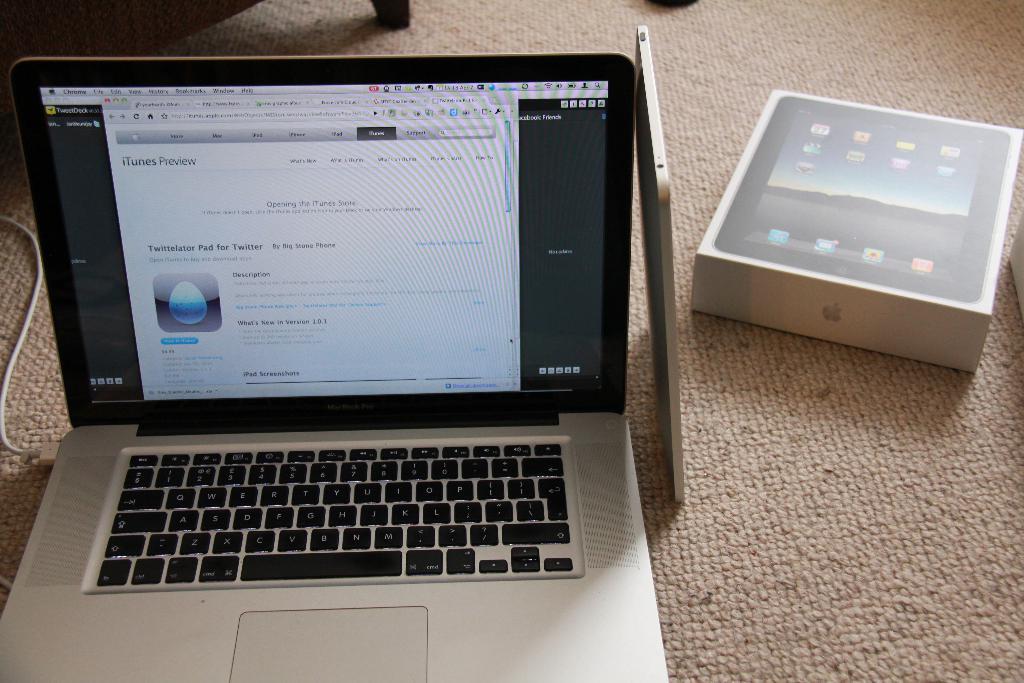What app is shown on itunes?
Offer a terse response. Twittelator pad for twitter. 